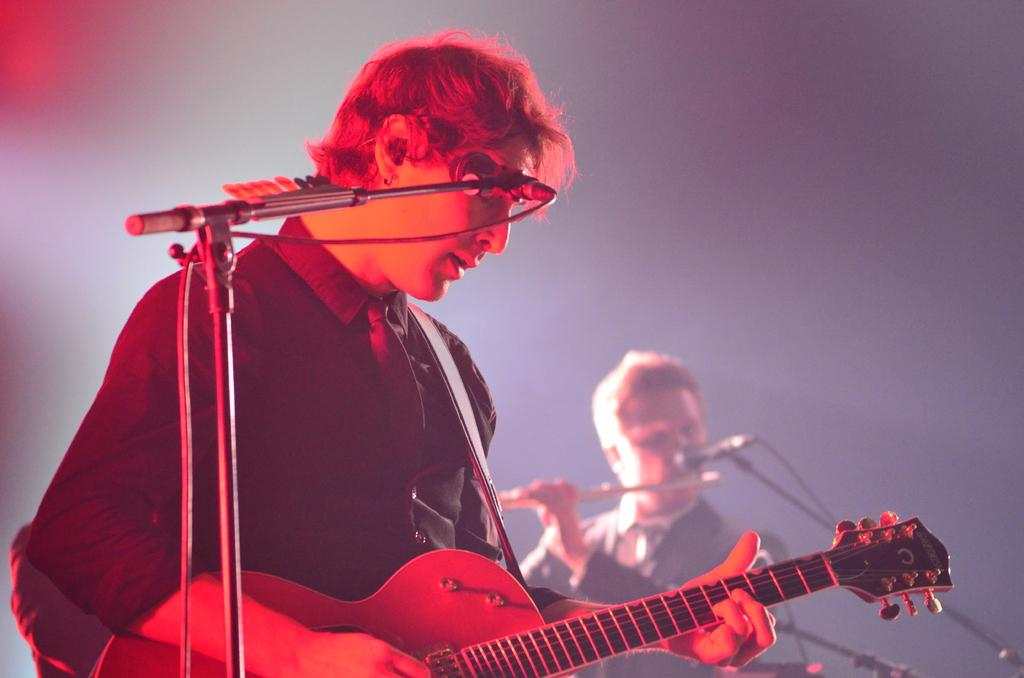What is the main subject of the image? The main subject of the image is a man. What is the man doing in the image? The man is playing musical instruments in the image. What object is present that is commonly used for amplifying sound? There is a microphone in the image. What type of disease is the man suffering from in the image? There is no indication of any disease in the image; the man is playing musical instruments. What type of pen is the man using to write music in the image? There is no pen present in the image, nor is there any indication that the man is writing music. 